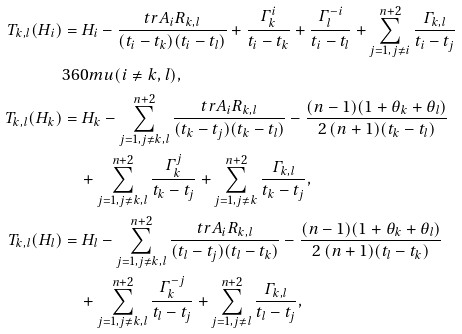Convert formula to latex. <formula><loc_0><loc_0><loc_500><loc_500>T _ { k , l } ( H _ { i } ) & = H _ { i } - \frac { t r A _ { i } R _ { k , l } } { ( t _ { i } - t _ { k } ) ( t _ { i } - t _ { l } ) } + \frac { \varGamma ^ { i } _ { k } } { t _ { i } - t _ { k } } + \frac { \varGamma ^ { - i } _ { l } } { t _ { i } - t _ { l } } + \sum _ { j = 1 , j \neq i } ^ { n + 2 } \frac { \varGamma _ { k , l } } { t _ { i } - t _ { j } } \\ & { 3 6 0 m u } ( i \neq k , l ) , \\ T _ { k , l } ( H _ { k } ) & = H _ { k } - \sum _ { j = 1 , j \neq k , l } ^ { n + 2 } \frac { t r A _ { i } R _ { k , l } } { ( t _ { k } - t _ { j } ) ( t _ { k } - t _ { l } ) } - \frac { ( n - 1 ) ( 1 + \theta _ { k } + \theta _ { l } ) } { 2 \, ( n + 1 ) ( t _ { k } - t _ { l } ) } \\ & \quad + \sum _ { j = 1 , j \neq k , l } ^ { n + 2 } \frac { \varGamma ^ { j } _ { k } } { t _ { k } - t _ { j } } + \sum _ { j = 1 , j \neq k } ^ { n + 2 } \frac { \varGamma _ { k , l } } { t _ { k } - t _ { j } } , \\ T _ { k , l } ( H _ { l } ) & = H _ { l } - \sum _ { j = 1 , j \neq k , l } ^ { n + 2 } \frac { t r A _ { i } R _ { k , l } } { ( t _ { l } - t _ { j } ) ( t _ { l } - t _ { k } ) } - \frac { ( n - 1 ) ( 1 + \theta _ { k } + \theta _ { l } ) } { 2 \, ( n + 1 ) ( t _ { l } - t _ { k } ) } \\ & \quad + \sum _ { j = 1 , j \neq k , l } ^ { n + 2 } \frac { \varGamma ^ { - j } _ { k } } { t _ { l } - t _ { j } } + \sum _ { j = 1 , j \neq l } ^ { n + 2 } \frac { \varGamma _ { k , l } } { t _ { l } - t _ { j } } ,</formula> 